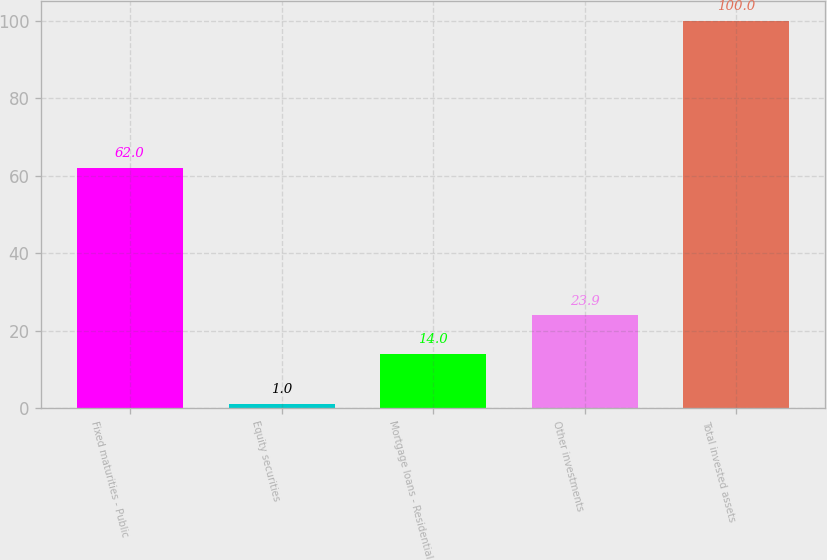Convert chart to OTSL. <chart><loc_0><loc_0><loc_500><loc_500><bar_chart><fcel>Fixed maturities - Public<fcel>Equity securities<fcel>Mortgage loans - Residential<fcel>Other investments<fcel>Total invested assets<nl><fcel>62<fcel>1<fcel>14<fcel>23.9<fcel>100<nl></chart> 